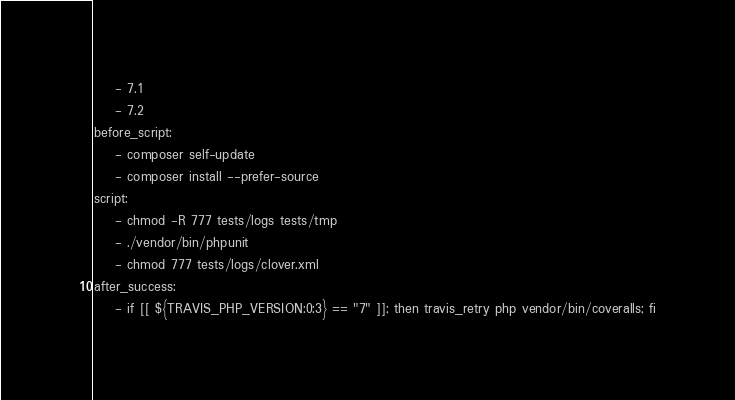<code> <loc_0><loc_0><loc_500><loc_500><_YAML_>    - 7.1
    - 7.2
before_script:
    - composer self-update
    - composer install --prefer-source
script:
    - chmod -R 777 tests/logs tests/tmp
    - ./vendor/bin/phpunit
    - chmod 777 tests/logs/clover.xml
after_success:
    - if [[ ${TRAVIS_PHP_VERSION:0:3} == "7" ]]; then travis_retry php vendor/bin/coveralls; fi
</code> 